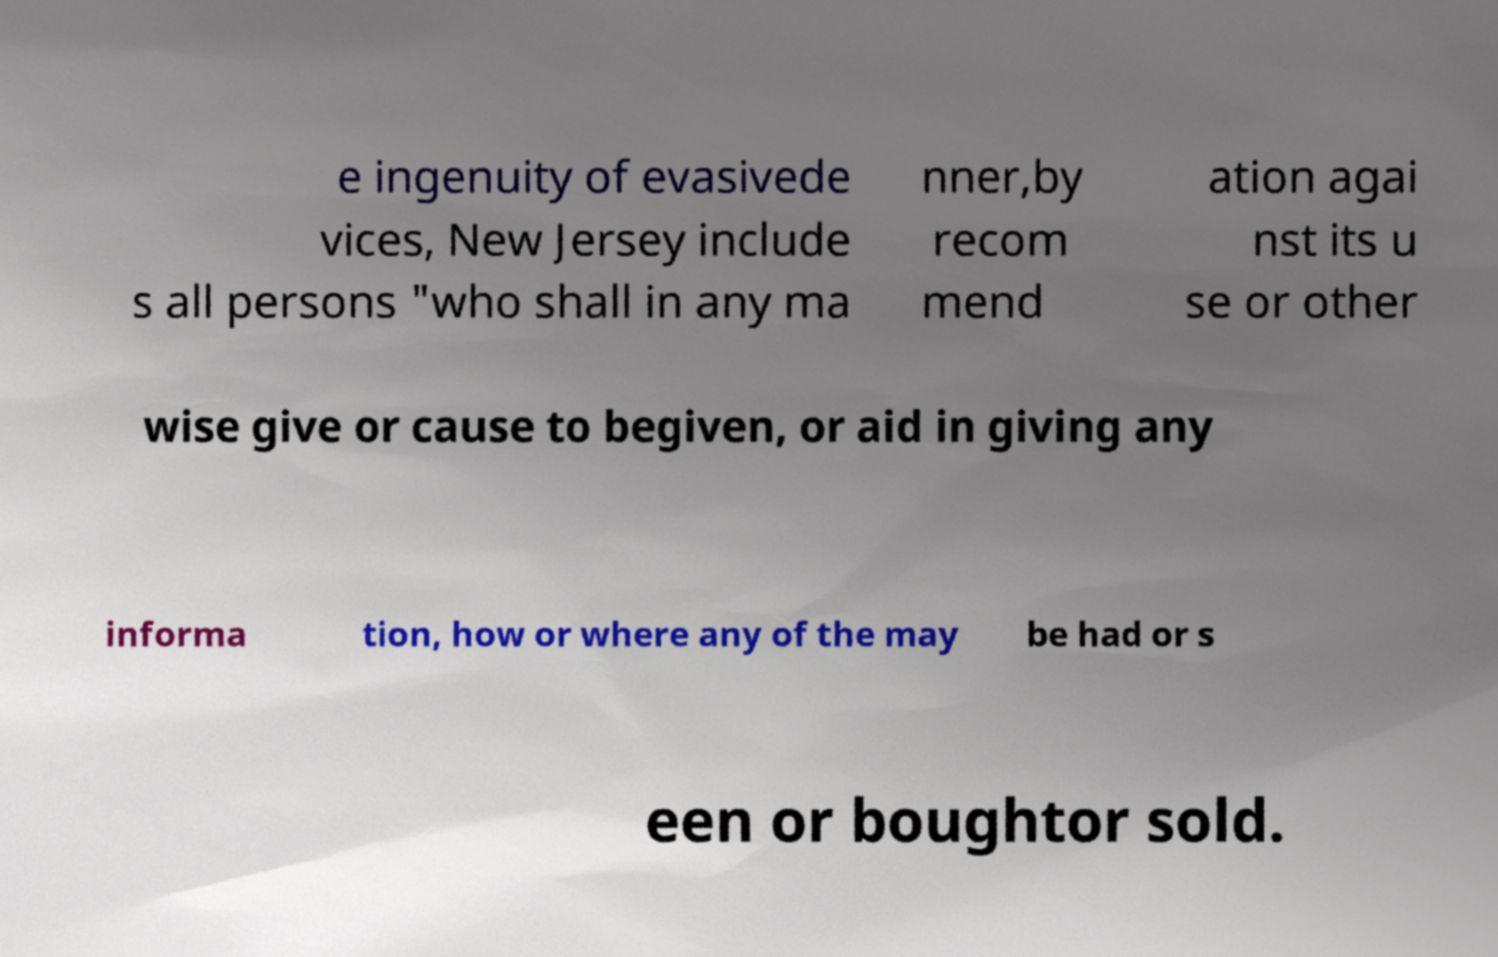Please identify and transcribe the text found in this image. e ingenuity of evasivede vices, New Jersey include s all persons "who shall in any ma nner,by recom mend ation agai nst its u se or other wise give or cause to begiven, or aid in giving any informa tion, how or where any of the may be had or s een or boughtor sold. 